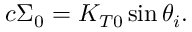Convert formula to latex. <formula><loc_0><loc_0><loc_500><loc_500>c \Sigma _ { 0 } = K _ { T 0 } \sin \theta _ { i } .</formula> 